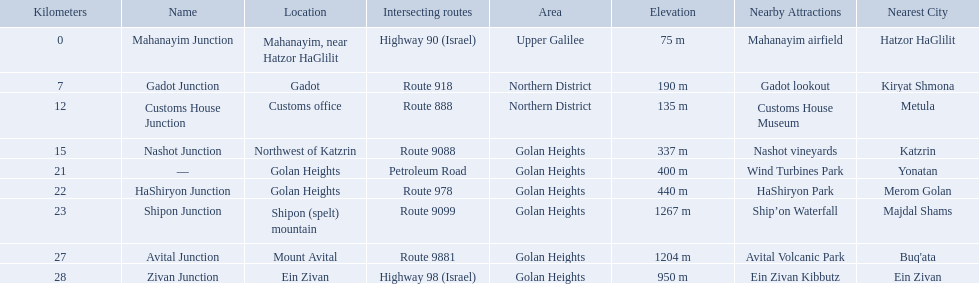Parse the table in full. {'header': ['Kilometers', 'Name', 'Location', 'Intersecting routes', 'Area', 'Elevation', 'Nearby Attractions', 'Nearest City'], 'rows': [['0', 'Mahanayim Junction', 'Mahanayim, near Hatzor HaGlilit', 'Highway 90 (Israel)', 'Upper Galilee', '75 m', 'Mahanayim airfield', 'Hatzor HaGlilit'], ['7', 'Gadot Junction', 'Gadot', 'Route 918', 'Northern District', '190 m', 'Gadot lookout', 'Kiryat Shmona'], ['12', 'Customs House Junction', 'Customs office', 'Route 888', 'Northern District', '135 m', 'Customs House Museum', 'Metula'], ['15', 'Nashot Junction', 'Northwest of Katzrin', 'Route 9088', 'Golan Heights', '337 m', 'Nashot vineyards', 'Katzrin'], ['21', '—', 'Golan Heights', 'Petroleum Road', 'Golan Heights', '400 m', 'Wind Turbines Park', 'Yonatan'], ['22', 'HaShiryon Junction', 'Golan Heights', 'Route 978', 'Golan Heights', '440 m', 'HaShiryon Park', 'Merom Golan'], ['23', 'Shipon Junction', 'Shipon (spelt) mountain', 'Route 9099', 'Golan Heights', '1267 m', 'Ship’on Waterfall', 'Majdal Shams'], ['27', 'Avital Junction', 'Mount Avital', 'Route 9881', 'Golan Heights', '1204 m', 'Avital Volcanic Park', "Buq'ata"], ['28', 'Zivan Junction', 'Ein Zivan', 'Highway 98 (Israel)', 'Golan Heights', '950 m', 'Ein Zivan Kibbutz', 'Ein Zivan']]} Which junctions are located on numbered routes, and not highways or other types? Gadot Junction, Customs House Junction, Nashot Junction, HaShiryon Junction, Shipon Junction, Avital Junction. Of these junctions, which ones are located on routes with four digits (ex. route 9999)? Nashot Junction, Shipon Junction, Avital Junction. Of the remaining routes, which is located on shipon (spelt) mountain? Shipon Junction. How many kilometers away is shipon junction? 23. How many kilometers away is avital junction? 27. Which one is closer to nashot junction? Shipon Junction. What are all the are all the locations on the highway 91 (israel)? Mahanayim, near Hatzor HaGlilit, Gadot, Customs office, Northwest of Katzrin, Golan Heights, Golan Heights, Shipon (spelt) mountain, Mount Avital, Ein Zivan. What are the distance values in kilometers for ein zivan, gadot junction and shipon junction? 7, 23, 28. Which is the least distance away? 7. What is the name? Gadot Junction. 